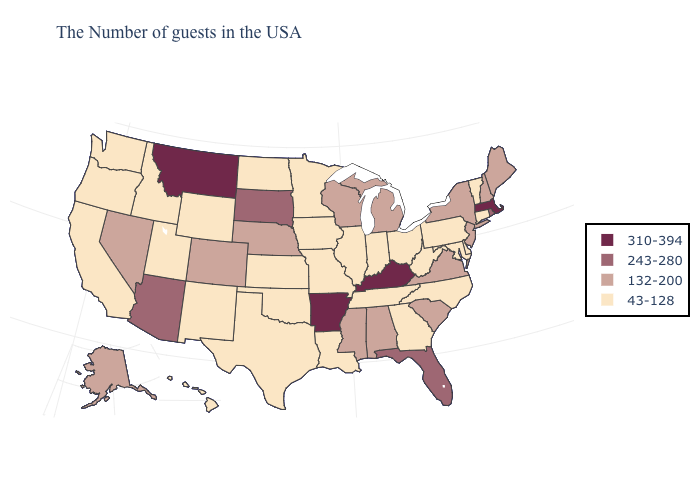What is the value of Mississippi?
Keep it brief. 132-200. Does Maine have a higher value than New Mexico?
Short answer required. Yes. Does the map have missing data?
Give a very brief answer. No. Does Wisconsin have a lower value than Nevada?
Quick response, please. No. Is the legend a continuous bar?
Concise answer only. No. Does Maryland have the lowest value in the USA?
Give a very brief answer. Yes. Does California have the highest value in the West?
Short answer required. No. Does Montana have the highest value in the USA?
Concise answer only. Yes. Name the states that have a value in the range 43-128?
Write a very short answer. Vermont, Connecticut, Delaware, Maryland, Pennsylvania, North Carolina, West Virginia, Ohio, Georgia, Indiana, Tennessee, Illinois, Louisiana, Missouri, Minnesota, Iowa, Kansas, Oklahoma, Texas, North Dakota, Wyoming, New Mexico, Utah, Idaho, California, Washington, Oregon, Hawaii. Among the states that border Pennsylvania , which have the highest value?
Answer briefly. New York, New Jersey. What is the value of Illinois?
Keep it brief. 43-128. Among the states that border Kentucky , does Virginia have the highest value?
Concise answer only. Yes. What is the lowest value in states that border Louisiana?
Give a very brief answer. 43-128. What is the value of Minnesota?
Keep it brief. 43-128. Does Oregon have a higher value than Tennessee?
Concise answer only. No. 